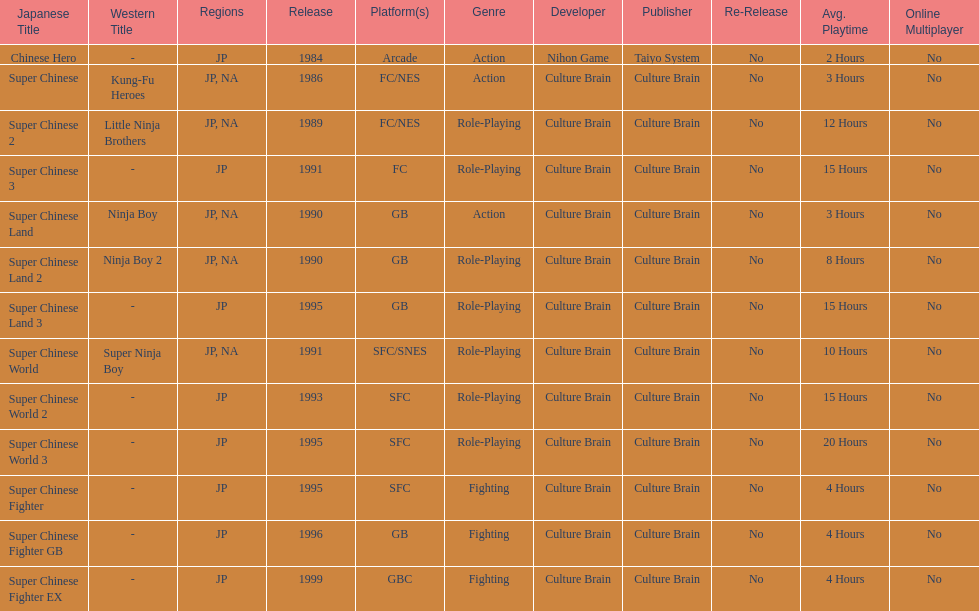The first year a game was released in north america 1986. 